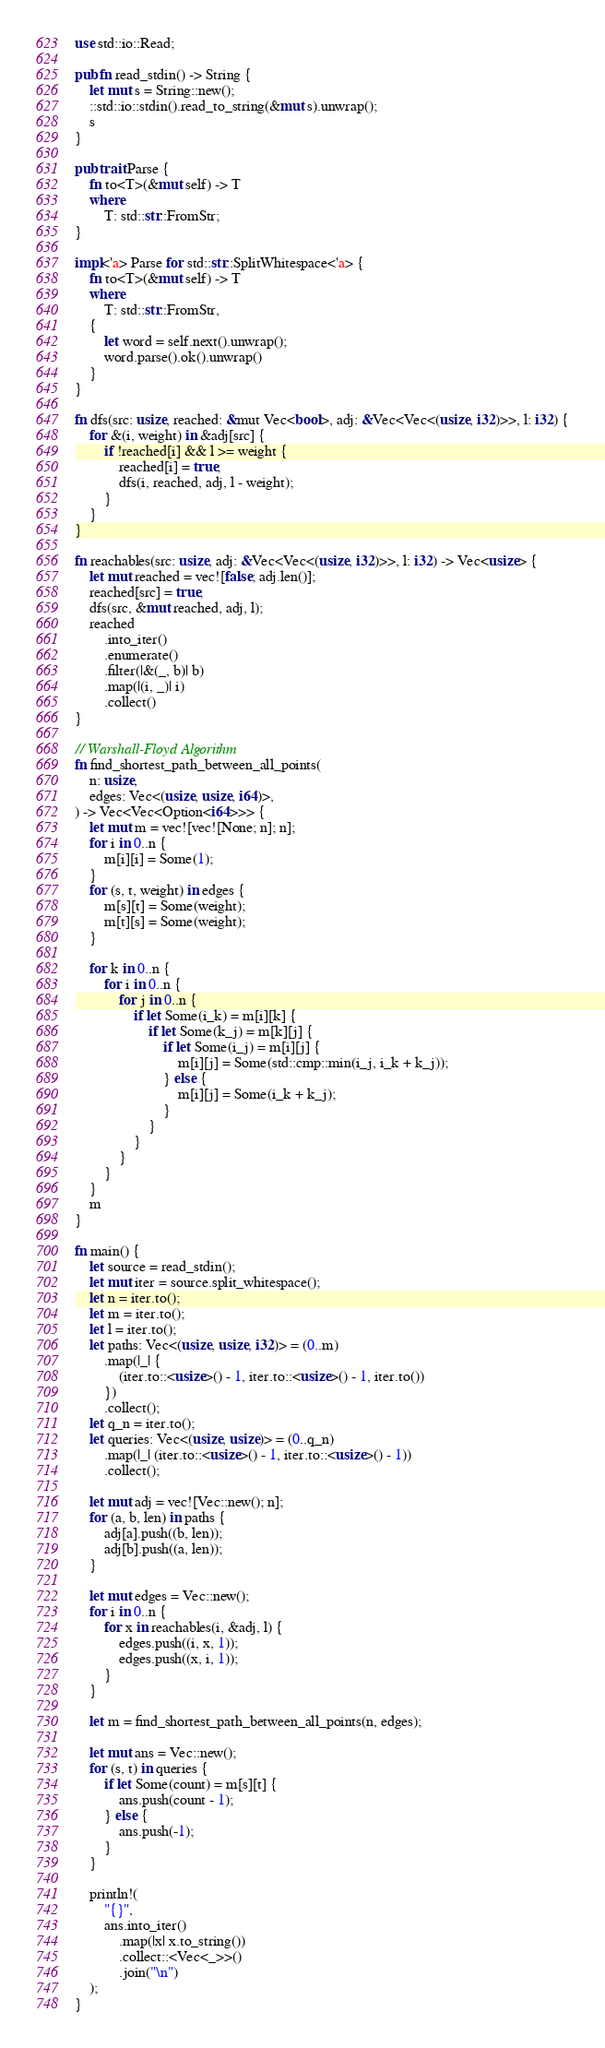<code> <loc_0><loc_0><loc_500><loc_500><_Rust_>use std::io::Read;

pub fn read_stdin() -> String {
    let mut s = String::new();
    ::std::io::stdin().read_to_string(&mut s).unwrap();
    s
}

pub trait Parse {
    fn to<T>(&mut self) -> T
    where
        T: std::str::FromStr;
}

impl<'a> Parse for std::str::SplitWhitespace<'a> {
    fn to<T>(&mut self) -> T
    where
        T: std::str::FromStr,
    {
        let word = self.next().unwrap();
        word.parse().ok().unwrap()
    }
}

fn dfs(src: usize, reached: &mut Vec<bool>, adj: &Vec<Vec<(usize, i32)>>, l: i32) {
    for &(i, weight) in &adj[src] {
        if !reached[i] && l >= weight {
            reached[i] = true;
            dfs(i, reached, adj, l - weight);
        }
    }
}

fn reachables(src: usize, adj: &Vec<Vec<(usize, i32)>>, l: i32) -> Vec<usize> {
    let mut reached = vec![false; adj.len()];
    reached[src] = true;
    dfs(src, &mut reached, adj, l);
    reached
        .into_iter()
        .enumerate()
        .filter(|&(_, b)| b)
        .map(|(i, _)| i)
        .collect()
}

// Warshall-Floyd Algorithm
fn find_shortest_path_between_all_points(
    n: usize,
    edges: Vec<(usize, usize, i64)>,
) -> Vec<Vec<Option<i64>>> {
    let mut m = vec![vec![None; n]; n];
    for i in 0..n {
        m[i][i] = Some(1);
    }
    for (s, t, weight) in edges {
        m[s][t] = Some(weight);
        m[t][s] = Some(weight);
    }

    for k in 0..n {
        for i in 0..n {
            for j in 0..n {
                if let Some(i_k) = m[i][k] {
                    if let Some(k_j) = m[k][j] {
                        if let Some(i_j) = m[i][j] {
                            m[i][j] = Some(std::cmp::min(i_j, i_k + k_j));
                        } else {
                            m[i][j] = Some(i_k + k_j);
                        }
                    }
                }
            }
        }
    }
    m
}

fn main() {
    let source = read_stdin();
    let mut iter = source.split_whitespace();
    let n = iter.to();
    let m = iter.to();
    let l = iter.to();
    let paths: Vec<(usize, usize, i32)> = (0..m)
        .map(|_| {
            (iter.to::<usize>() - 1, iter.to::<usize>() - 1, iter.to())
        })
        .collect();
    let q_n = iter.to();
    let queries: Vec<(usize, usize)> = (0..q_n)
        .map(|_| (iter.to::<usize>() - 1, iter.to::<usize>() - 1))
        .collect();

    let mut adj = vec![Vec::new(); n];
    for (a, b, len) in paths {
        adj[a].push((b, len));
        adj[b].push((a, len));
    }

    let mut edges = Vec::new();
    for i in 0..n {
        for x in reachables(i, &adj, l) {
            edges.push((i, x, 1));
            edges.push((x, i, 1));
        }
    }

    let m = find_shortest_path_between_all_points(n, edges);

    let mut ans = Vec::new();
    for (s, t) in queries {
        if let Some(count) = m[s][t] {
            ans.push(count - 1);
        } else {
            ans.push(-1);
        }
    }

    println!(
        "{}",
        ans.into_iter()
            .map(|x| x.to_string())
            .collect::<Vec<_>>()
            .join("\n")
    );
}</code> 